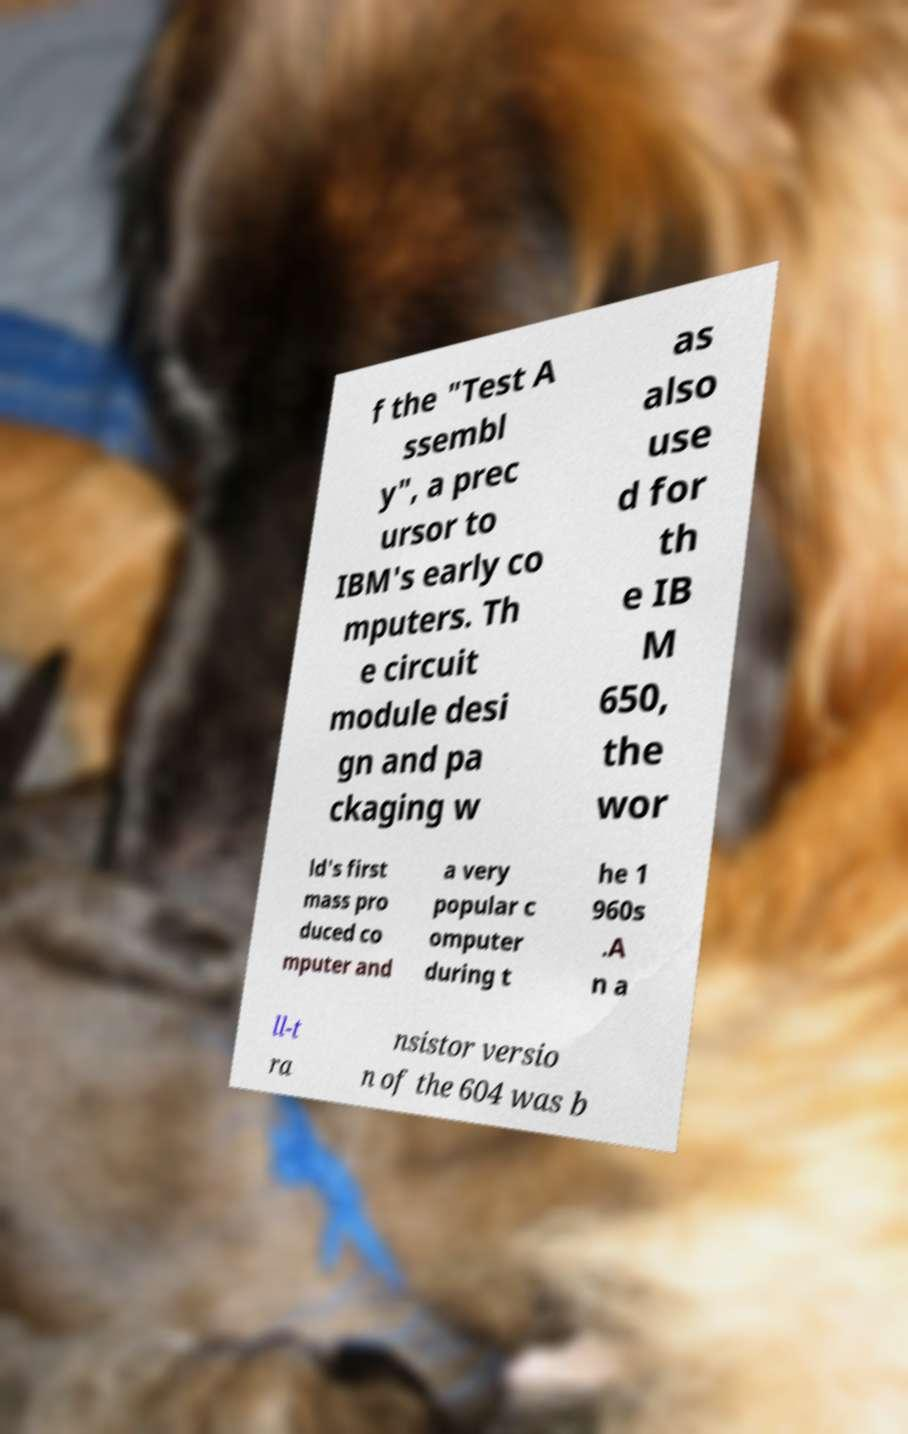For documentation purposes, I need the text within this image transcribed. Could you provide that? f the "Test A ssembl y", a prec ursor to IBM's early co mputers. Th e circuit module desi gn and pa ckaging w as also use d for th e IB M 650, the wor ld's first mass pro duced co mputer and a very popular c omputer during t he 1 960s .A n a ll-t ra nsistor versio n of the 604 was b 